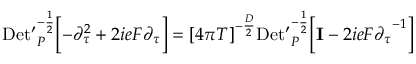<formula> <loc_0><loc_0><loc_500><loc_500>D e t ^ { \prime } _ { P } ^ { - { \frac { 1 } { 2 } } } \left [ - { \partial } _ { \tau } ^ { 2 } + 2 i e F { \partial } _ { \tau } \right ] = { [ 4 \pi T ] } ^ { - { \frac { D } { 2 } } } D e t ^ { \prime } _ { P } ^ { - { \frac { 1 } { 2 } } } \left [ { I } - 2 i e F { { \partial } _ { \tau } } ^ { - 1 } \right ]</formula> 